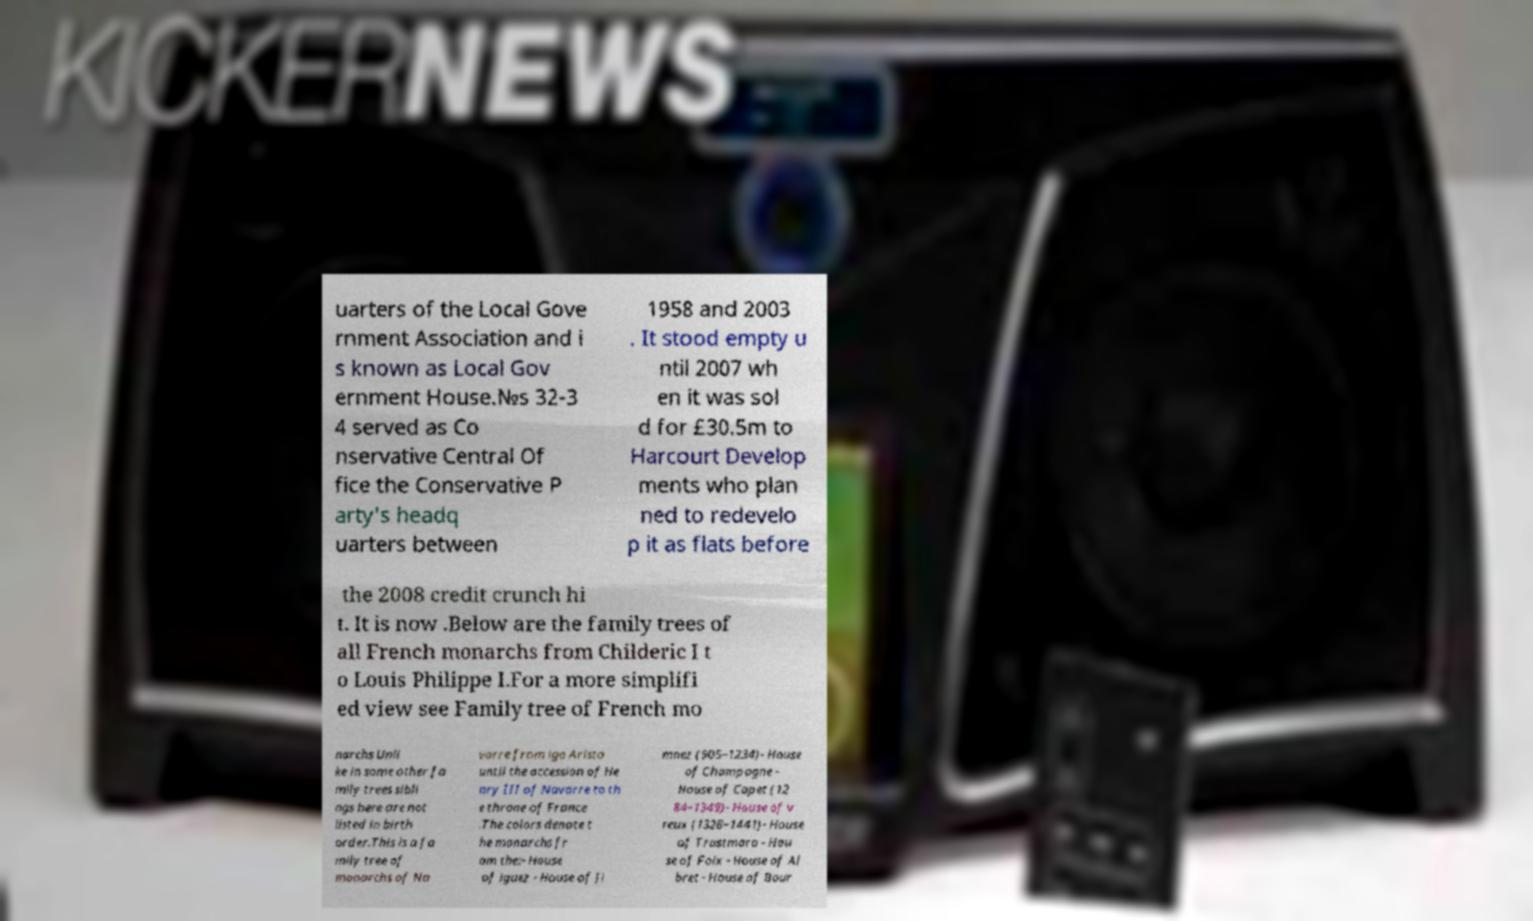Can you accurately transcribe the text from the provided image for me? uarters of the Local Gove rnment Association and i s known as Local Gov ernment House.№s 32-3 4 served as Co nservative Central Of fice the Conservative P arty's headq uarters between 1958 and 2003 . It stood empty u ntil 2007 wh en it was sol d for £30.5m to Harcourt Develop ments who plan ned to redevelo p it as flats before the 2008 credit crunch hi t. It is now .Below are the family trees of all French monarchs from Childeric I t o Louis Philippe I.For a more simplifi ed view see Family tree of French mo narchs Unli ke in some other fa mily trees sibli ngs here are not listed in birth order.This is a fa mily tree of monarchs of Na varre from igo Arista until the accession of He nry III of Navarre to th e throne of France .The colors denote t he monarchs fr om the:- House of iguez - House of Ji mnez (905–1234)- House of Champagne - House of Capet (12 84–1349)- House of v reux (1328–1441)- House of Trastmara - Hou se of Foix - House of Al bret - House of Bour 